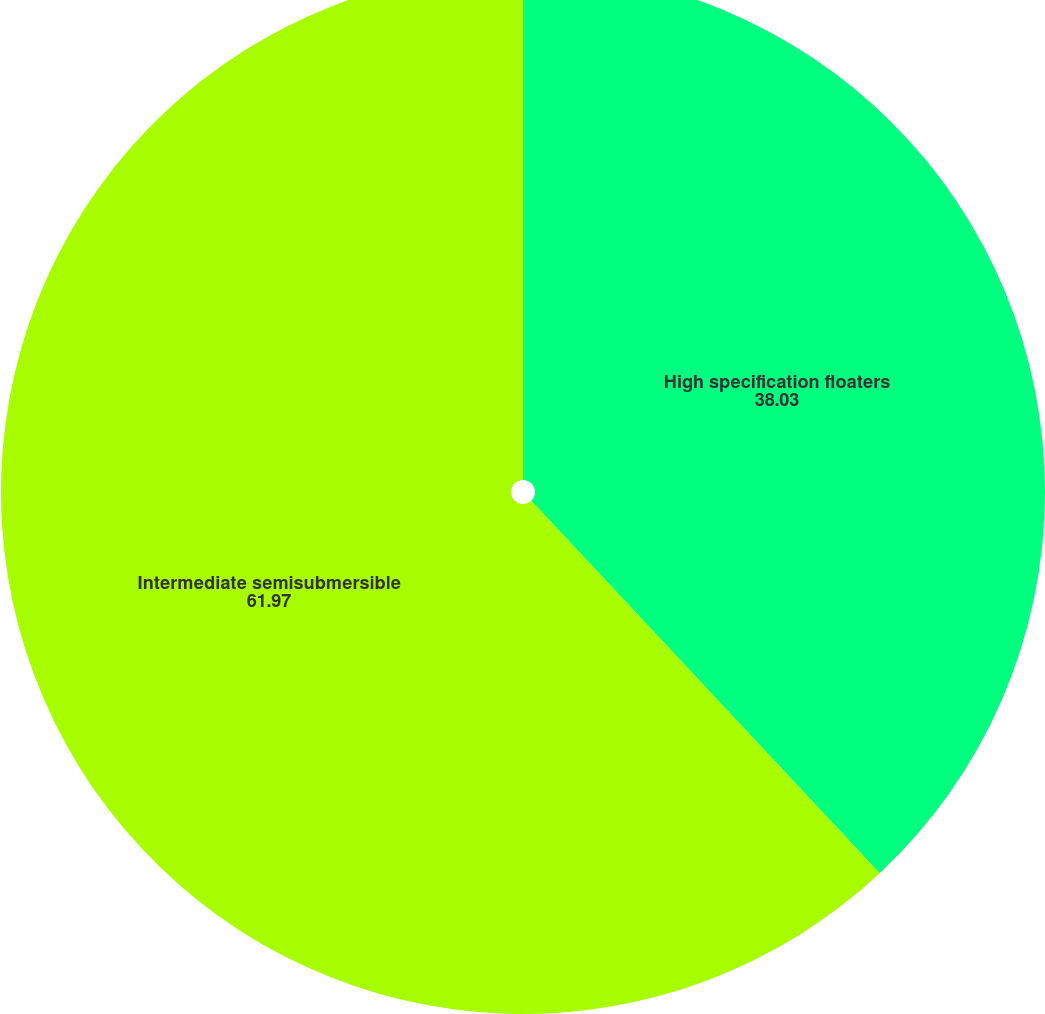Convert chart to OTSL. <chart><loc_0><loc_0><loc_500><loc_500><pie_chart><fcel>High specification floaters<fcel>Intermediate semisubmersible<nl><fcel>38.03%<fcel>61.97%<nl></chart> 